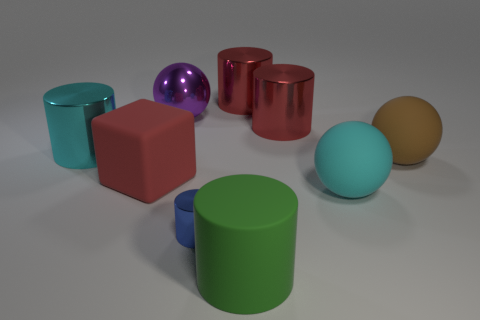Subtract all red cylinders. How many cylinders are left? 3 Subtract all large matte balls. How many balls are left? 1 Add 1 red rubber things. How many objects exist? 10 Subtract all cyan cylinders. Subtract all brown spheres. How many cylinders are left? 4 Subtract all cylinders. How many objects are left? 4 Add 6 purple things. How many purple things exist? 7 Subtract 1 brown spheres. How many objects are left? 8 Subtract all brown objects. Subtract all purple spheres. How many objects are left? 7 Add 6 cyan rubber things. How many cyan rubber things are left? 7 